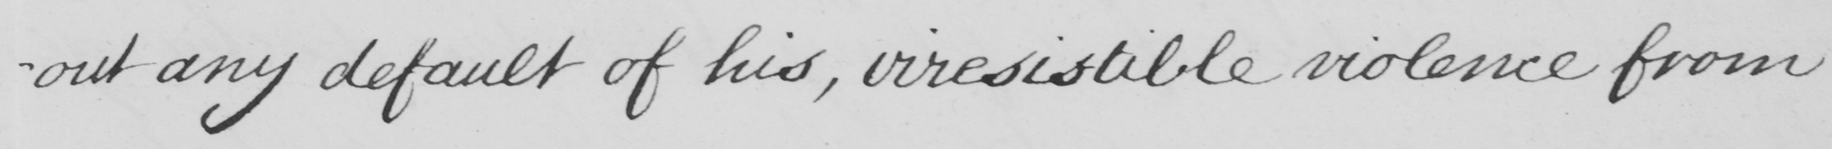Please provide the text content of this handwritten line. -out any default of his , irresistible violence from 